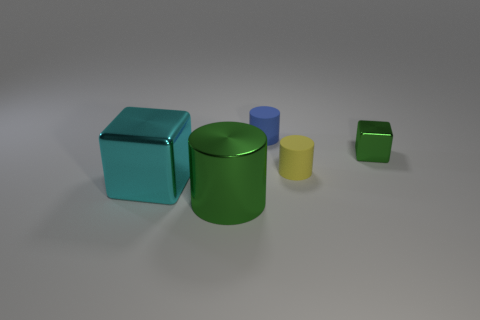If these shapes were part of a puzzle, how might they fit together? If these shapes were part of a puzzle, one could imagine the cubes and cylinders forming a three-dimensional structure, potentially interlocking by placing the cylinders atop the flat faces of the cubes, or aligning them side by side to form patterns or a balanced configuration.  Could you create a story using these objects? Absolutely! Picture a miniature world where the big turquoise cube is the central meeting hall, the green cylinder is the town's grain silo, the small blue cylinder is a water tower, the yellow one is a lighthouse, and the tiny green cube is a community garden. Together, they form the essential structures of a vibrant, geometric village. 